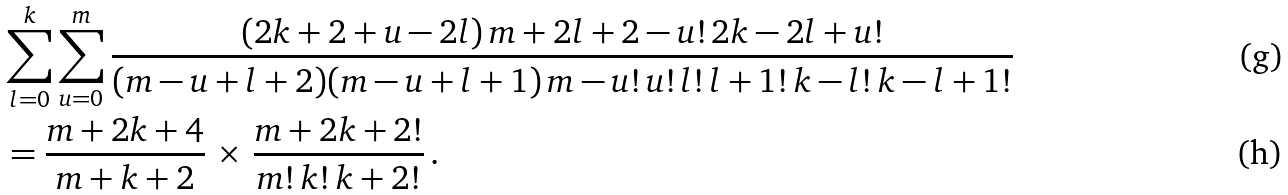<formula> <loc_0><loc_0><loc_500><loc_500>& \sum _ { l = 0 } ^ { k } \sum _ { u = 0 } ^ { m } \frac { ( 2 k + 2 + u - 2 l ) \, m + 2 l + 2 - u ! \, 2 k - 2 l + u ! } { ( m - u + l + 2 ) ( m - u + l + 1 ) \, m - u ! \, u ! \, l ! \, l + 1 ! \, k - l ! \, k - l + 1 ! } \\ & = \frac { m + 2 k + 4 } { m + k + 2 } \, \times \, \frac { m + 2 k + 2 ! } { m ! \, k ! \, k + 2 ! } \, .</formula> 